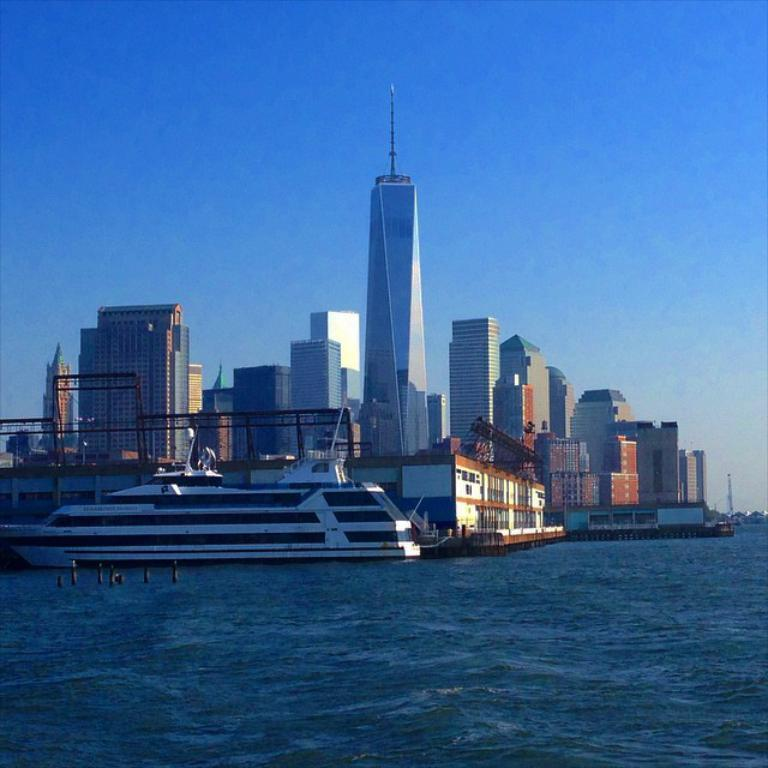What is the primary element visible in the image? There is water in the image. What can be seen in the distance behind the water? There are buildings and skyscrapers in the background of the image. What is visible at the top of the image? The sky is visible at the top of the image. How many fish can be seen swimming in the water in the image? There are no fish visible in the image; it only features water, buildings, skyscrapers, and the sky. 